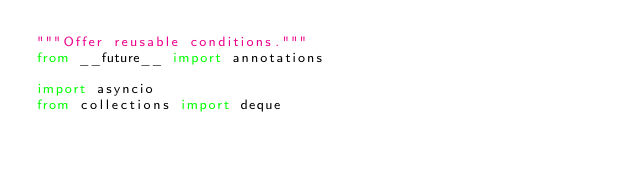<code> <loc_0><loc_0><loc_500><loc_500><_Python_>"""Offer reusable conditions."""
from __future__ import annotations

import asyncio
from collections import deque</code> 